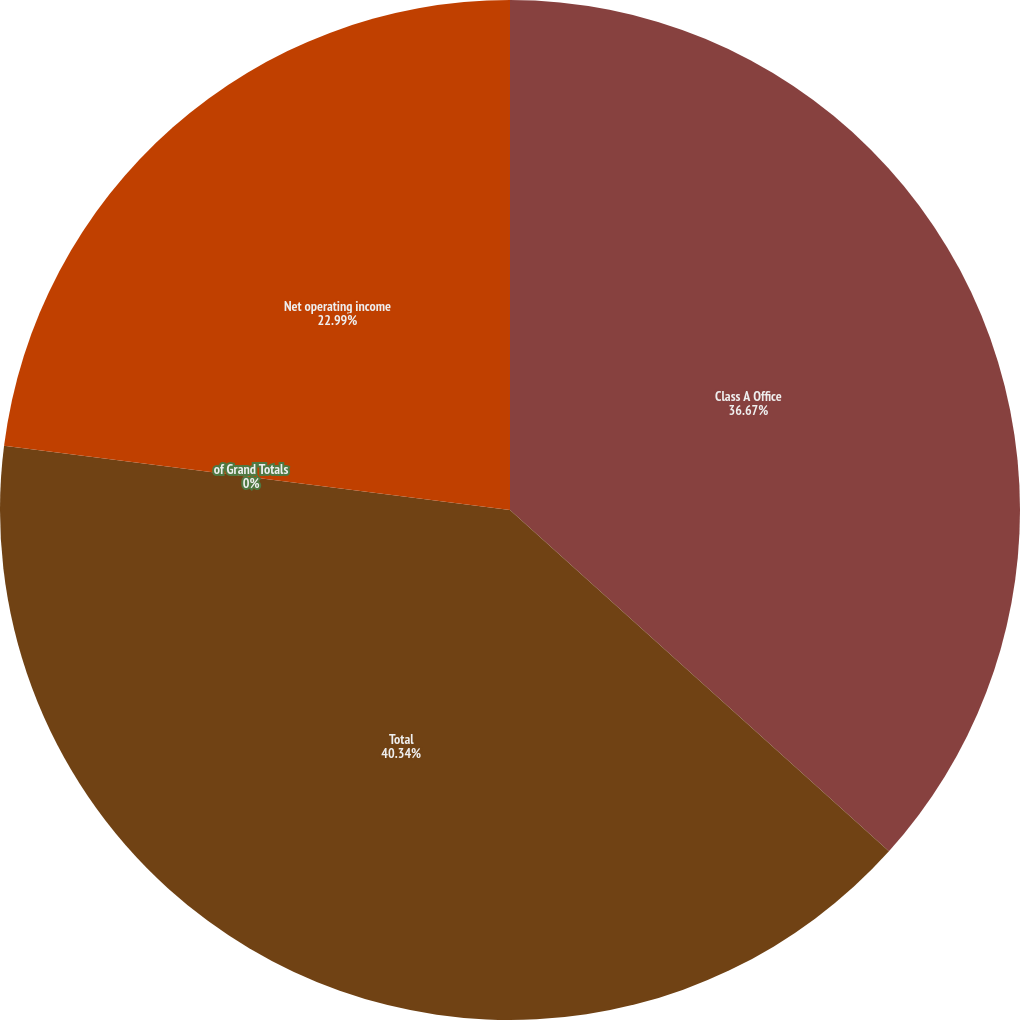Convert chart. <chart><loc_0><loc_0><loc_500><loc_500><pie_chart><fcel>Class A Office<fcel>Total<fcel>of Grand Totals<fcel>Net operating income<nl><fcel>36.67%<fcel>40.34%<fcel>0.0%<fcel>22.99%<nl></chart> 